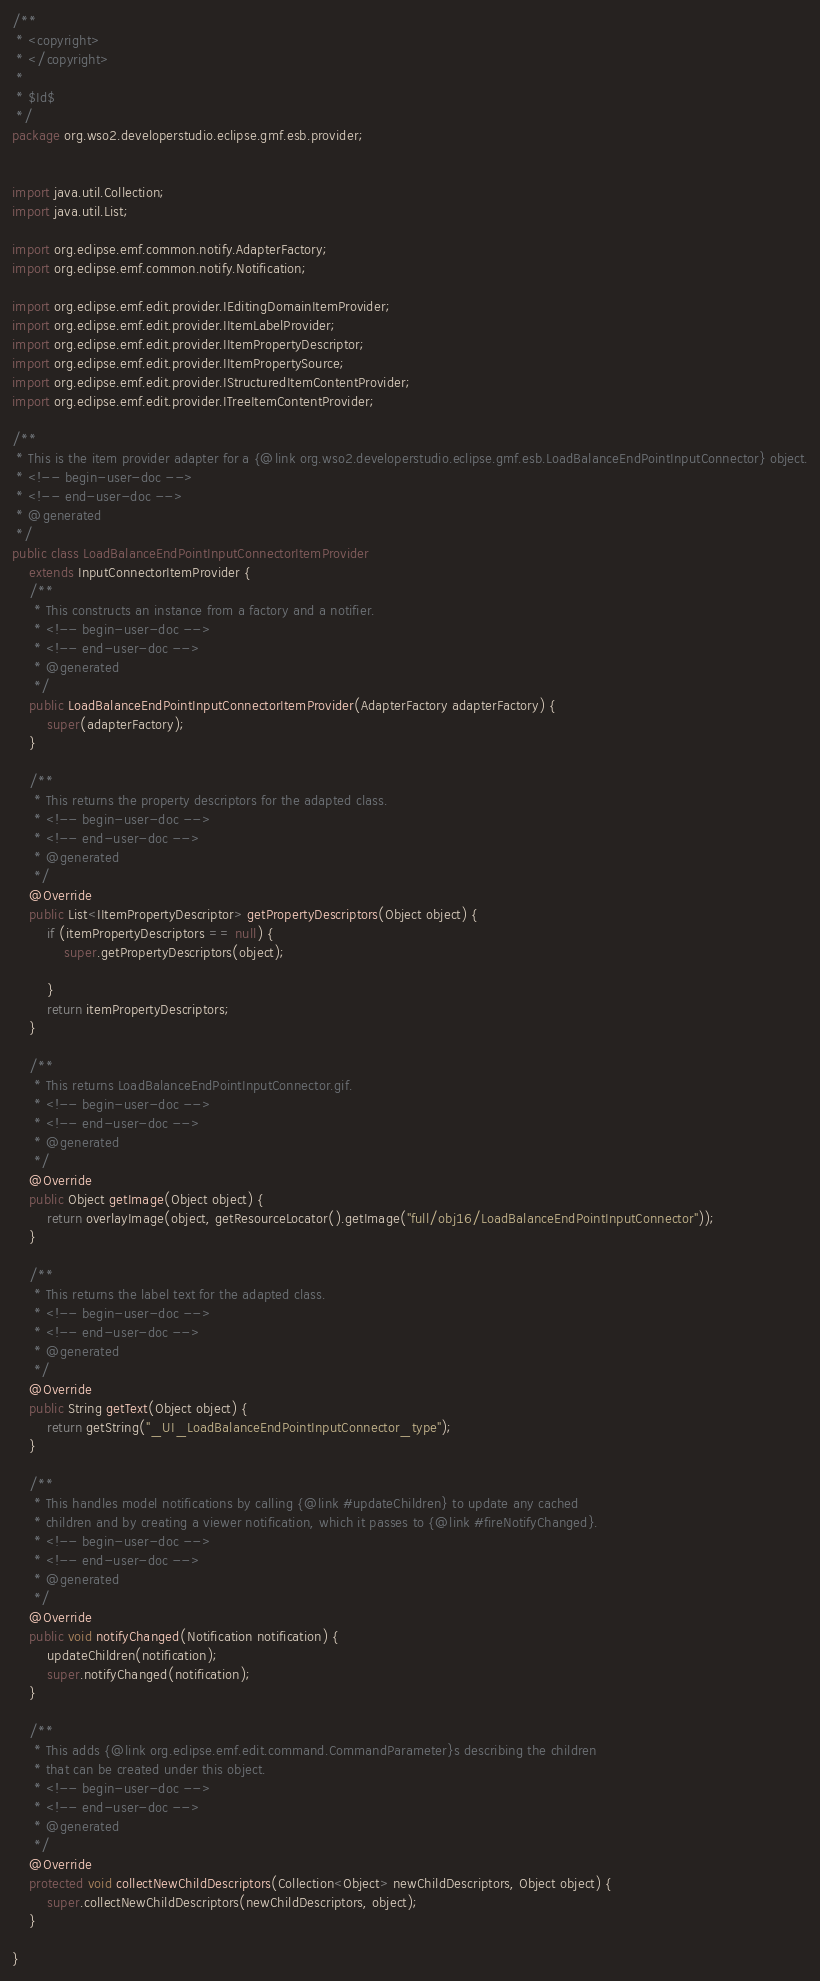<code> <loc_0><loc_0><loc_500><loc_500><_Java_>/**
 * <copyright>
 * </copyright>
 *
 * $Id$
 */
package org.wso2.developerstudio.eclipse.gmf.esb.provider;


import java.util.Collection;
import java.util.List;

import org.eclipse.emf.common.notify.AdapterFactory;
import org.eclipse.emf.common.notify.Notification;

import org.eclipse.emf.edit.provider.IEditingDomainItemProvider;
import org.eclipse.emf.edit.provider.IItemLabelProvider;
import org.eclipse.emf.edit.provider.IItemPropertyDescriptor;
import org.eclipse.emf.edit.provider.IItemPropertySource;
import org.eclipse.emf.edit.provider.IStructuredItemContentProvider;
import org.eclipse.emf.edit.provider.ITreeItemContentProvider;

/**
 * This is the item provider adapter for a {@link org.wso2.developerstudio.eclipse.gmf.esb.LoadBalanceEndPointInputConnector} object.
 * <!-- begin-user-doc -->
 * <!-- end-user-doc -->
 * @generated
 */
public class LoadBalanceEndPointInputConnectorItemProvider
	extends InputConnectorItemProvider {
	/**
	 * This constructs an instance from a factory and a notifier.
	 * <!-- begin-user-doc -->
	 * <!-- end-user-doc -->
	 * @generated
	 */
	public LoadBalanceEndPointInputConnectorItemProvider(AdapterFactory adapterFactory) {
		super(adapterFactory);
	}

	/**
	 * This returns the property descriptors for the adapted class.
	 * <!-- begin-user-doc -->
	 * <!-- end-user-doc -->
	 * @generated
	 */
	@Override
	public List<IItemPropertyDescriptor> getPropertyDescriptors(Object object) {
		if (itemPropertyDescriptors == null) {
			super.getPropertyDescriptors(object);

		}
		return itemPropertyDescriptors;
	}

	/**
	 * This returns LoadBalanceEndPointInputConnector.gif.
	 * <!-- begin-user-doc -->
	 * <!-- end-user-doc -->
	 * @generated
	 */
	@Override
	public Object getImage(Object object) {
		return overlayImage(object, getResourceLocator().getImage("full/obj16/LoadBalanceEndPointInputConnector"));
	}

	/**
	 * This returns the label text for the adapted class.
	 * <!-- begin-user-doc -->
	 * <!-- end-user-doc -->
	 * @generated
	 */
	@Override
	public String getText(Object object) {
		return getString("_UI_LoadBalanceEndPointInputConnector_type");
	}

	/**
	 * This handles model notifications by calling {@link #updateChildren} to update any cached
	 * children and by creating a viewer notification, which it passes to {@link #fireNotifyChanged}.
	 * <!-- begin-user-doc -->
	 * <!-- end-user-doc -->
	 * @generated
	 */
	@Override
	public void notifyChanged(Notification notification) {
		updateChildren(notification);
		super.notifyChanged(notification);
	}

	/**
	 * This adds {@link org.eclipse.emf.edit.command.CommandParameter}s describing the children
	 * that can be created under this object.
	 * <!-- begin-user-doc -->
	 * <!-- end-user-doc -->
	 * @generated
	 */
	@Override
	protected void collectNewChildDescriptors(Collection<Object> newChildDescriptors, Object object) {
		super.collectNewChildDescriptors(newChildDescriptors, object);
	}

}
</code> 